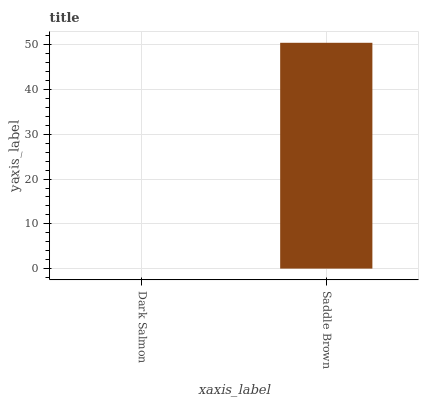Is Dark Salmon the minimum?
Answer yes or no. Yes. Is Saddle Brown the maximum?
Answer yes or no. Yes. Is Saddle Brown the minimum?
Answer yes or no. No. Is Saddle Brown greater than Dark Salmon?
Answer yes or no. Yes. Is Dark Salmon less than Saddle Brown?
Answer yes or no. Yes. Is Dark Salmon greater than Saddle Brown?
Answer yes or no. No. Is Saddle Brown less than Dark Salmon?
Answer yes or no. No. Is Saddle Brown the high median?
Answer yes or no. Yes. Is Dark Salmon the low median?
Answer yes or no. Yes. Is Dark Salmon the high median?
Answer yes or no. No. Is Saddle Brown the low median?
Answer yes or no. No. 